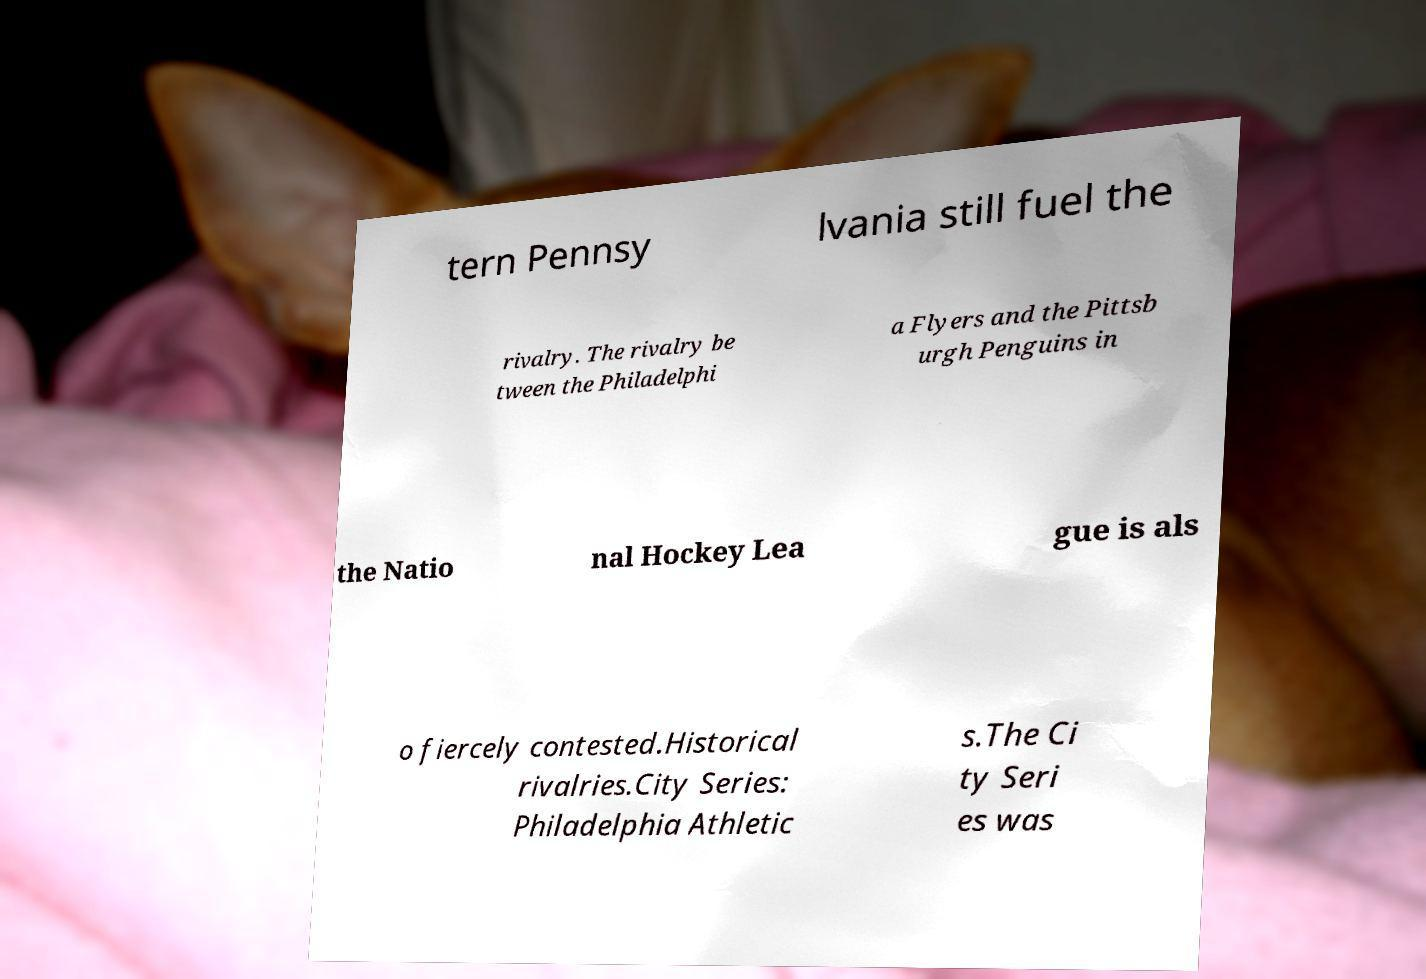Could you assist in decoding the text presented in this image and type it out clearly? tern Pennsy lvania still fuel the rivalry. The rivalry be tween the Philadelphi a Flyers and the Pittsb urgh Penguins in the Natio nal Hockey Lea gue is als o fiercely contested.Historical rivalries.City Series: Philadelphia Athletic s.The Ci ty Seri es was 